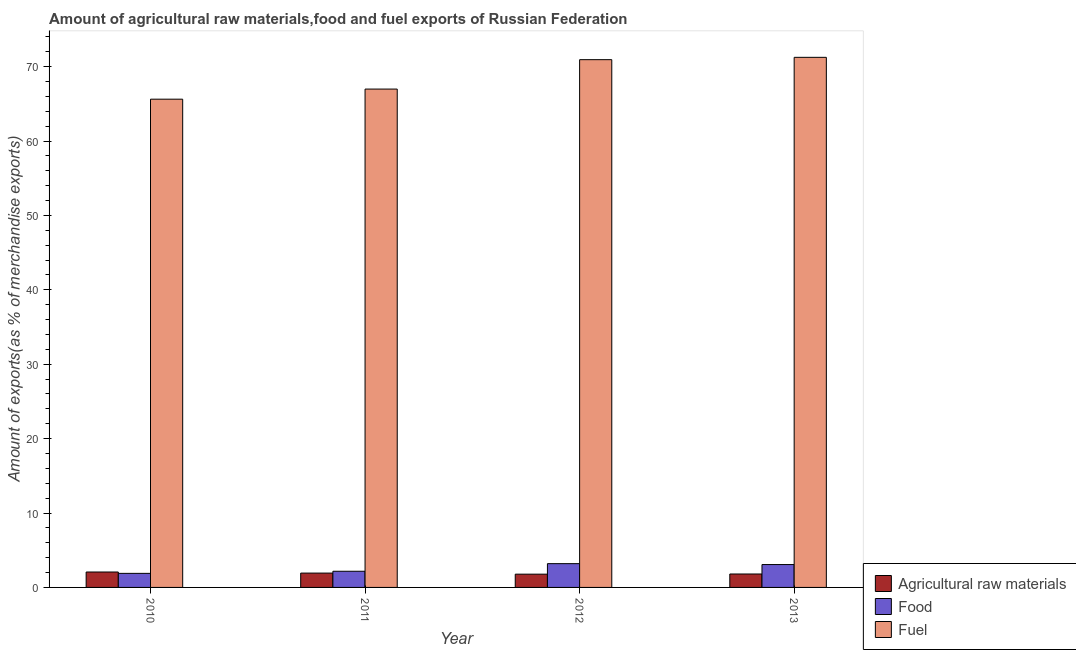How many groups of bars are there?
Your response must be concise. 4. Are the number of bars per tick equal to the number of legend labels?
Keep it short and to the point. Yes. How many bars are there on the 2nd tick from the left?
Your answer should be compact. 3. How many bars are there on the 1st tick from the right?
Make the answer very short. 3. What is the label of the 1st group of bars from the left?
Offer a terse response. 2010. In how many cases, is the number of bars for a given year not equal to the number of legend labels?
Offer a terse response. 0. What is the percentage of food exports in 2012?
Keep it short and to the point. 3.2. Across all years, what is the maximum percentage of fuel exports?
Provide a succinct answer. 71.25. Across all years, what is the minimum percentage of fuel exports?
Your answer should be very brief. 65.62. In which year was the percentage of raw materials exports minimum?
Offer a very short reply. 2012. What is the total percentage of raw materials exports in the graph?
Your answer should be very brief. 7.59. What is the difference between the percentage of fuel exports in 2011 and that in 2013?
Make the answer very short. -4.27. What is the difference between the percentage of fuel exports in 2013 and the percentage of raw materials exports in 2012?
Your answer should be very brief. 0.31. What is the average percentage of food exports per year?
Ensure brevity in your answer.  2.58. In the year 2012, what is the difference between the percentage of food exports and percentage of raw materials exports?
Ensure brevity in your answer.  0. What is the ratio of the percentage of fuel exports in 2011 to that in 2013?
Ensure brevity in your answer.  0.94. Is the percentage of fuel exports in 2010 less than that in 2011?
Keep it short and to the point. Yes. What is the difference between the highest and the second highest percentage of food exports?
Provide a succinct answer. 0.12. What is the difference between the highest and the lowest percentage of fuel exports?
Provide a short and direct response. 5.63. In how many years, is the percentage of raw materials exports greater than the average percentage of raw materials exports taken over all years?
Your answer should be very brief. 2. What does the 2nd bar from the left in 2011 represents?
Ensure brevity in your answer.  Food. What does the 1st bar from the right in 2012 represents?
Offer a very short reply. Fuel. How many bars are there?
Offer a very short reply. 12. Are all the bars in the graph horizontal?
Make the answer very short. No. What is the difference between two consecutive major ticks on the Y-axis?
Keep it short and to the point. 10. Does the graph contain any zero values?
Offer a very short reply. No. What is the title of the graph?
Your answer should be very brief. Amount of agricultural raw materials,food and fuel exports of Russian Federation. Does "Profit Tax" appear as one of the legend labels in the graph?
Offer a very short reply. No. What is the label or title of the X-axis?
Provide a succinct answer. Year. What is the label or title of the Y-axis?
Provide a short and direct response. Amount of exports(as % of merchandise exports). What is the Amount of exports(as % of merchandise exports) of Agricultural raw materials in 2010?
Offer a very short reply. 2.07. What is the Amount of exports(as % of merchandise exports) of Food in 2010?
Offer a terse response. 1.89. What is the Amount of exports(as % of merchandise exports) in Fuel in 2010?
Ensure brevity in your answer.  65.62. What is the Amount of exports(as % of merchandise exports) in Agricultural raw materials in 2011?
Offer a very short reply. 1.93. What is the Amount of exports(as % of merchandise exports) in Food in 2011?
Provide a succinct answer. 2.17. What is the Amount of exports(as % of merchandise exports) in Fuel in 2011?
Give a very brief answer. 66.98. What is the Amount of exports(as % of merchandise exports) of Agricultural raw materials in 2012?
Provide a succinct answer. 1.78. What is the Amount of exports(as % of merchandise exports) in Food in 2012?
Your answer should be compact. 3.2. What is the Amount of exports(as % of merchandise exports) of Fuel in 2012?
Your answer should be compact. 70.93. What is the Amount of exports(as % of merchandise exports) of Agricultural raw materials in 2013?
Your response must be concise. 1.8. What is the Amount of exports(as % of merchandise exports) of Food in 2013?
Give a very brief answer. 3.07. What is the Amount of exports(as % of merchandise exports) of Fuel in 2013?
Make the answer very short. 71.25. Across all years, what is the maximum Amount of exports(as % of merchandise exports) in Agricultural raw materials?
Offer a very short reply. 2.07. Across all years, what is the maximum Amount of exports(as % of merchandise exports) in Food?
Your response must be concise. 3.2. Across all years, what is the maximum Amount of exports(as % of merchandise exports) in Fuel?
Provide a succinct answer. 71.25. Across all years, what is the minimum Amount of exports(as % of merchandise exports) in Agricultural raw materials?
Make the answer very short. 1.78. Across all years, what is the minimum Amount of exports(as % of merchandise exports) in Food?
Your response must be concise. 1.89. Across all years, what is the minimum Amount of exports(as % of merchandise exports) of Fuel?
Your answer should be compact. 65.62. What is the total Amount of exports(as % of merchandise exports) in Agricultural raw materials in the graph?
Your response must be concise. 7.59. What is the total Amount of exports(as % of merchandise exports) of Food in the graph?
Make the answer very short. 10.33. What is the total Amount of exports(as % of merchandise exports) in Fuel in the graph?
Your answer should be very brief. 274.79. What is the difference between the Amount of exports(as % of merchandise exports) of Agricultural raw materials in 2010 and that in 2011?
Ensure brevity in your answer.  0.14. What is the difference between the Amount of exports(as % of merchandise exports) in Food in 2010 and that in 2011?
Your answer should be compact. -0.28. What is the difference between the Amount of exports(as % of merchandise exports) in Fuel in 2010 and that in 2011?
Provide a succinct answer. -1.36. What is the difference between the Amount of exports(as % of merchandise exports) of Agricultural raw materials in 2010 and that in 2012?
Your answer should be very brief. 0.29. What is the difference between the Amount of exports(as % of merchandise exports) of Food in 2010 and that in 2012?
Provide a short and direct response. -1.31. What is the difference between the Amount of exports(as % of merchandise exports) of Fuel in 2010 and that in 2012?
Your response must be concise. -5.31. What is the difference between the Amount of exports(as % of merchandise exports) in Agricultural raw materials in 2010 and that in 2013?
Provide a short and direct response. 0.27. What is the difference between the Amount of exports(as % of merchandise exports) in Food in 2010 and that in 2013?
Keep it short and to the point. -1.18. What is the difference between the Amount of exports(as % of merchandise exports) in Fuel in 2010 and that in 2013?
Ensure brevity in your answer.  -5.63. What is the difference between the Amount of exports(as % of merchandise exports) in Agricultural raw materials in 2011 and that in 2012?
Keep it short and to the point. 0.14. What is the difference between the Amount of exports(as % of merchandise exports) in Food in 2011 and that in 2012?
Provide a short and direct response. -1.02. What is the difference between the Amount of exports(as % of merchandise exports) of Fuel in 2011 and that in 2012?
Keep it short and to the point. -3.95. What is the difference between the Amount of exports(as % of merchandise exports) in Agricultural raw materials in 2011 and that in 2013?
Your answer should be compact. 0.12. What is the difference between the Amount of exports(as % of merchandise exports) in Food in 2011 and that in 2013?
Offer a terse response. -0.9. What is the difference between the Amount of exports(as % of merchandise exports) in Fuel in 2011 and that in 2013?
Your answer should be compact. -4.27. What is the difference between the Amount of exports(as % of merchandise exports) of Agricultural raw materials in 2012 and that in 2013?
Provide a succinct answer. -0.02. What is the difference between the Amount of exports(as % of merchandise exports) of Food in 2012 and that in 2013?
Keep it short and to the point. 0.12. What is the difference between the Amount of exports(as % of merchandise exports) of Fuel in 2012 and that in 2013?
Provide a short and direct response. -0.31. What is the difference between the Amount of exports(as % of merchandise exports) of Agricultural raw materials in 2010 and the Amount of exports(as % of merchandise exports) of Food in 2011?
Ensure brevity in your answer.  -0.1. What is the difference between the Amount of exports(as % of merchandise exports) in Agricultural raw materials in 2010 and the Amount of exports(as % of merchandise exports) in Fuel in 2011?
Your answer should be compact. -64.91. What is the difference between the Amount of exports(as % of merchandise exports) of Food in 2010 and the Amount of exports(as % of merchandise exports) of Fuel in 2011?
Ensure brevity in your answer.  -65.09. What is the difference between the Amount of exports(as % of merchandise exports) of Agricultural raw materials in 2010 and the Amount of exports(as % of merchandise exports) of Food in 2012?
Your answer should be compact. -1.12. What is the difference between the Amount of exports(as % of merchandise exports) in Agricultural raw materials in 2010 and the Amount of exports(as % of merchandise exports) in Fuel in 2012?
Offer a terse response. -68.86. What is the difference between the Amount of exports(as % of merchandise exports) of Food in 2010 and the Amount of exports(as % of merchandise exports) of Fuel in 2012?
Keep it short and to the point. -69.04. What is the difference between the Amount of exports(as % of merchandise exports) of Agricultural raw materials in 2010 and the Amount of exports(as % of merchandise exports) of Food in 2013?
Provide a succinct answer. -1. What is the difference between the Amount of exports(as % of merchandise exports) in Agricultural raw materials in 2010 and the Amount of exports(as % of merchandise exports) in Fuel in 2013?
Offer a very short reply. -69.18. What is the difference between the Amount of exports(as % of merchandise exports) of Food in 2010 and the Amount of exports(as % of merchandise exports) of Fuel in 2013?
Ensure brevity in your answer.  -69.36. What is the difference between the Amount of exports(as % of merchandise exports) in Agricultural raw materials in 2011 and the Amount of exports(as % of merchandise exports) in Food in 2012?
Your answer should be very brief. -1.27. What is the difference between the Amount of exports(as % of merchandise exports) in Agricultural raw materials in 2011 and the Amount of exports(as % of merchandise exports) in Fuel in 2012?
Offer a terse response. -69.01. What is the difference between the Amount of exports(as % of merchandise exports) of Food in 2011 and the Amount of exports(as % of merchandise exports) of Fuel in 2012?
Provide a short and direct response. -68.76. What is the difference between the Amount of exports(as % of merchandise exports) of Agricultural raw materials in 2011 and the Amount of exports(as % of merchandise exports) of Food in 2013?
Ensure brevity in your answer.  -1.15. What is the difference between the Amount of exports(as % of merchandise exports) of Agricultural raw materials in 2011 and the Amount of exports(as % of merchandise exports) of Fuel in 2013?
Your response must be concise. -69.32. What is the difference between the Amount of exports(as % of merchandise exports) of Food in 2011 and the Amount of exports(as % of merchandise exports) of Fuel in 2013?
Ensure brevity in your answer.  -69.07. What is the difference between the Amount of exports(as % of merchandise exports) in Agricultural raw materials in 2012 and the Amount of exports(as % of merchandise exports) in Food in 2013?
Keep it short and to the point. -1.29. What is the difference between the Amount of exports(as % of merchandise exports) of Agricultural raw materials in 2012 and the Amount of exports(as % of merchandise exports) of Fuel in 2013?
Your response must be concise. -69.46. What is the difference between the Amount of exports(as % of merchandise exports) of Food in 2012 and the Amount of exports(as % of merchandise exports) of Fuel in 2013?
Keep it short and to the point. -68.05. What is the average Amount of exports(as % of merchandise exports) in Agricultural raw materials per year?
Ensure brevity in your answer.  1.9. What is the average Amount of exports(as % of merchandise exports) in Food per year?
Make the answer very short. 2.58. What is the average Amount of exports(as % of merchandise exports) in Fuel per year?
Ensure brevity in your answer.  68.7. In the year 2010, what is the difference between the Amount of exports(as % of merchandise exports) in Agricultural raw materials and Amount of exports(as % of merchandise exports) in Food?
Your response must be concise. 0.18. In the year 2010, what is the difference between the Amount of exports(as % of merchandise exports) of Agricultural raw materials and Amount of exports(as % of merchandise exports) of Fuel?
Keep it short and to the point. -63.55. In the year 2010, what is the difference between the Amount of exports(as % of merchandise exports) in Food and Amount of exports(as % of merchandise exports) in Fuel?
Offer a terse response. -63.73. In the year 2011, what is the difference between the Amount of exports(as % of merchandise exports) of Agricultural raw materials and Amount of exports(as % of merchandise exports) of Food?
Your answer should be compact. -0.25. In the year 2011, what is the difference between the Amount of exports(as % of merchandise exports) in Agricultural raw materials and Amount of exports(as % of merchandise exports) in Fuel?
Provide a short and direct response. -65.06. In the year 2011, what is the difference between the Amount of exports(as % of merchandise exports) in Food and Amount of exports(as % of merchandise exports) in Fuel?
Your response must be concise. -64.81. In the year 2012, what is the difference between the Amount of exports(as % of merchandise exports) in Agricultural raw materials and Amount of exports(as % of merchandise exports) in Food?
Provide a short and direct response. -1.41. In the year 2012, what is the difference between the Amount of exports(as % of merchandise exports) in Agricultural raw materials and Amount of exports(as % of merchandise exports) in Fuel?
Your answer should be compact. -69.15. In the year 2012, what is the difference between the Amount of exports(as % of merchandise exports) in Food and Amount of exports(as % of merchandise exports) in Fuel?
Ensure brevity in your answer.  -67.74. In the year 2013, what is the difference between the Amount of exports(as % of merchandise exports) in Agricultural raw materials and Amount of exports(as % of merchandise exports) in Food?
Keep it short and to the point. -1.27. In the year 2013, what is the difference between the Amount of exports(as % of merchandise exports) in Agricultural raw materials and Amount of exports(as % of merchandise exports) in Fuel?
Your answer should be very brief. -69.44. In the year 2013, what is the difference between the Amount of exports(as % of merchandise exports) in Food and Amount of exports(as % of merchandise exports) in Fuel?
Provide a succinct answer. -68.17. What is the ratio of the Amount of exports(as % of merchandise exports) in Agricultural raw materials in 2010 to that in 2011?
Your answer should be compact. 1.07. What is the ratio of the Amount of exports(as % of merchandise exports) in Food in 2010 to that in 2011?
Keep it short and to the point. 0.87. What is the ratio of the Amount of exports(as % of merchandise exports) of Fuel in 2010 to that in 2011?
Ensure brevity in your answer.  0.98. What is the ratio of the Amount of exports(as % of merchandise exports) in Agricultural raw materials in 2010 to that in 2012?
Ensure brevity in your answer.  1.16. What is the ratio of the Amount of exports(as % of merchandise exports) in Food in 2010 to that in 2012?
Keep it short and to the point. 0.59. What is the ratio of the Amount of exports(as % of merchandise exports) in Fuel in 2010 to that in 2012?
Give a very brief answer. 0.93. What is the ratio of the Amount of exports(as % of merchandise exports) of Agricultural raw materials in 2010 to that in 2013?
Your answer should be compact. 1.15. What is the ratio of the Amount of exports(as % of merchandise exports) in Food in 2010 to that in 2013?
Provide a succinct answer. 0.61. What is the ratio of the Amount of exports(as % of merchandise exports) of Fuel in 2010 to that in 2013?
Ensure brevity in your answer.  0.92. What is the ratio of the Amount of exports(as % of merchandise exports) in Agricultural raw materials in 2011 to that in 2012?
Provide a succinct answer. 1.08. What is the ratio of the Amount of exports(as % of merchandise exports) in Food in 2011 to that in 2012?
Offer a terse response. 0.68. What is the ratio of the Amount of exports(as % of merchandise exports) of Fuel in 2011 to that in 2012?
Keep it short and to the point. 0.94. What is the ratio of the Amount of exports(as % of merchandise exports) in Agricultural raw materials in 2011 to that in 2013?
Offer a very short reply. 1.07. What is the ratio of the Amount of exports(as % of merchandise exports) in Food in 2011 to that in 2013?
Your response must be concise. 0.71. What is the ratio of the Amount of exports(as % of merchandise exports) in Fuel in 2011 to that in 2013?
Provide a succinct answer. 0.94. What is the ratio of the Amount of exports(as % of merchandise exports) of Food in 2012 to that in 2013?
Your response must be concise. 1.04. What is the ratio of the Amount of exports(as % of merchandise exports) in Fuel in 2012 to that in 2013?
Provide a succinct answer. 1. What is the difference between the highest and the second highest Amount of exports(as % of merchandise exports) of Agricultural raw materials?
Offer a terse response. 0.14. What is the difference between the highest and the second highest Amount of exports(as % of merchandise exports) of Food?
Give a very brief answer. 0.12. What is the difference between the highest and the second highest Amount of exports(as % of merchandise exports) of Fuel?
Make the answer very short. 0.31. What is the difference between the highest and the lowest Amount of exports(as % of merchandise exports) of Agricultural raw materials?
Offer a terse response. 0.29. What is the difference between the highest and the lowest Amount of exports(as % of merchandise exports) of Food?
Provide a succinct answer. 1.31. What is the difference between the highest and the lowest Amount of exports(as % of merchandise exports) in Fuel?
Keep it short and to the point. 5.63. 